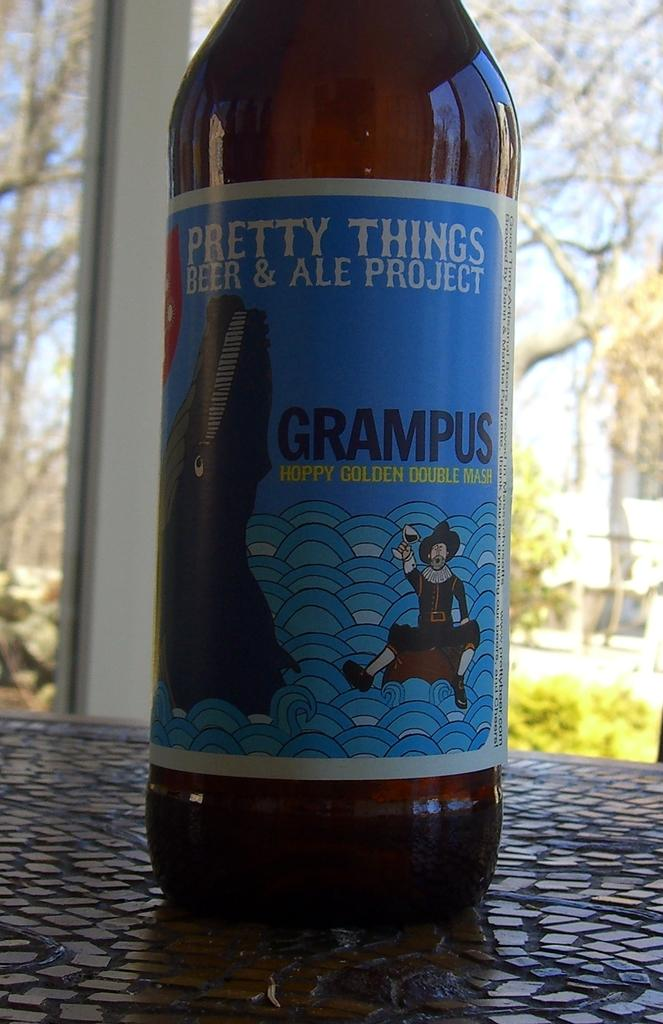<image>
Give a short and clear explanation of the subsequent image. Pretty things beer is on a broken glass table 